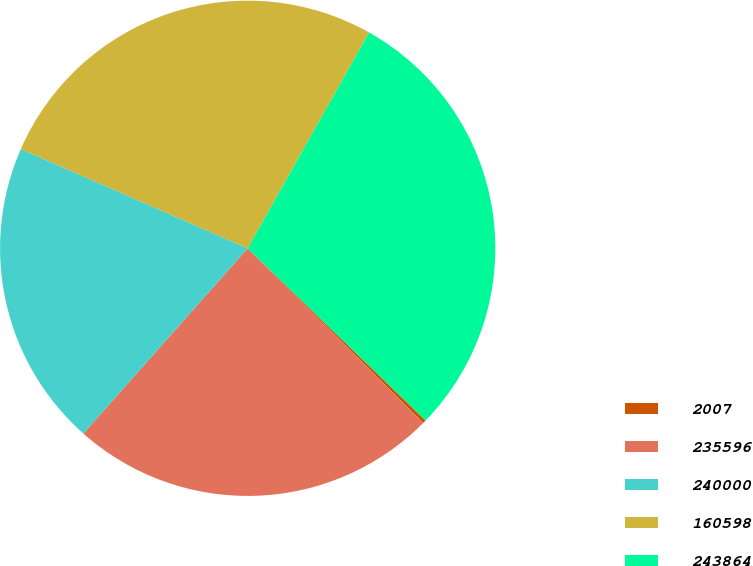Convert chart. <chart><loc_0><loc_0><loc_500><loc_500><pie_chart><fcel>2007<fcel>235596<fcel>240000<fcel>160598<fcel>243864<nl><fcel>0.22%<fcel>24.09%<fcel>20.02%<fcel>26.59%<fcel>29.09%<nl></chart> 